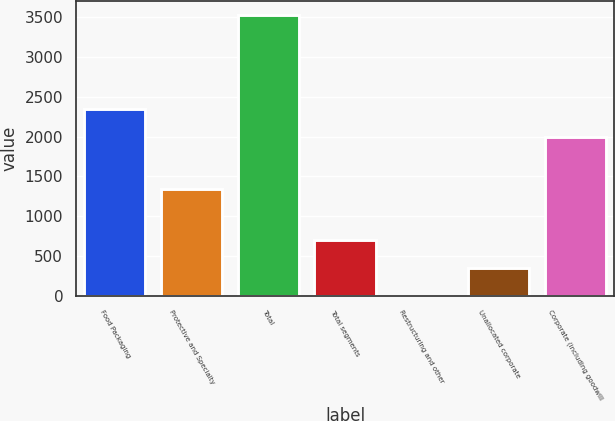Convert chart to OTSL. <chart><loc_0><loc_0><loc_500><loc_500><bar_chart><fcel>Food Packaging<fcel>Protective and Specialty<fcel>Total<fcel>Total segments<fcel>Restructuring and other<fcel>Unallocated corporate<fcel>Corporate (including goodwill<nl><fcel>2349.34<fcel>1346.2<fcel>3531.9<fcel>706.78<fcel>0.5<fcel>353.64<fcel>1996.2<nl></chart> 